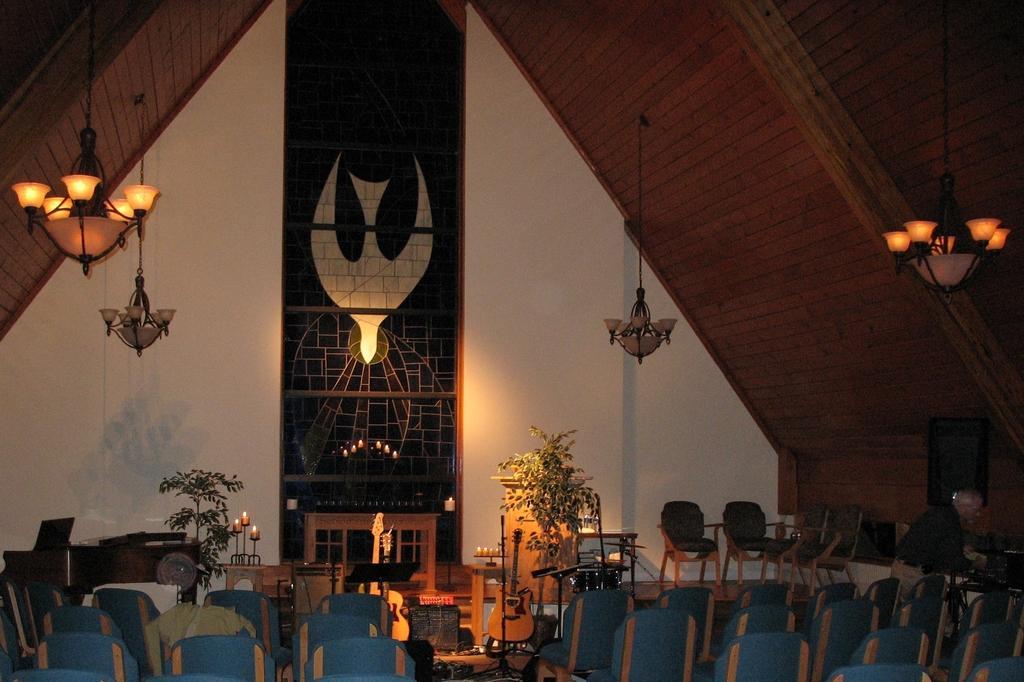Describe this image in one or two sentences. In this image there are chairs, plants, tables, on that tables there are candles, at the top there is a roof and there are lights, in the background there is a wall. 